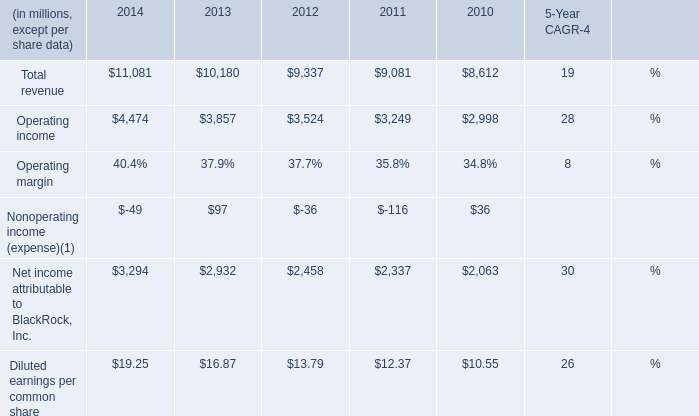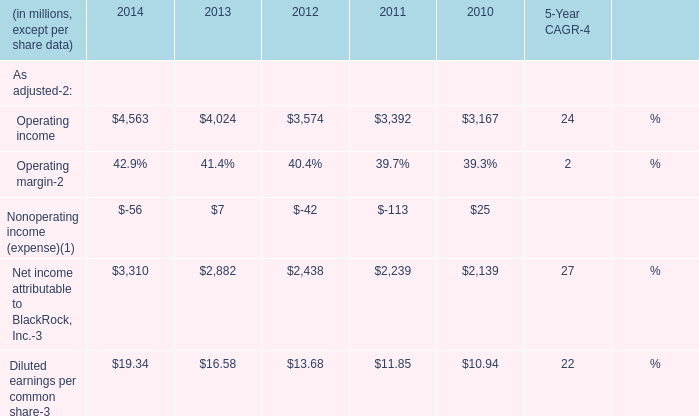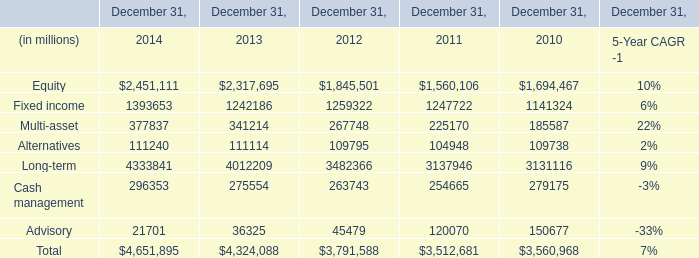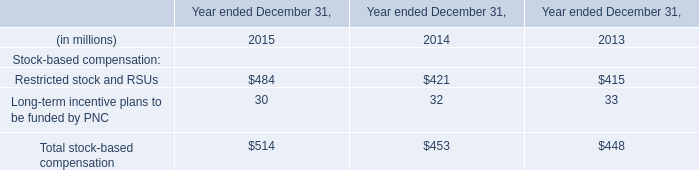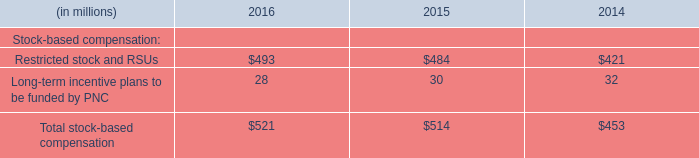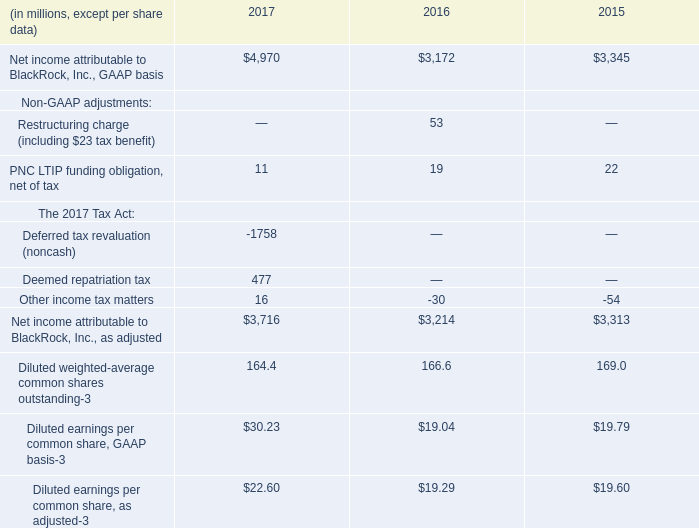If Equity develops with the same growth rate in 2014, what will it reach in 2015? (in millions) 
Computations: ((1 + ((2451111 - 2317695) / 2317695)) * 2451111)
Answer: 2592206.97043. 